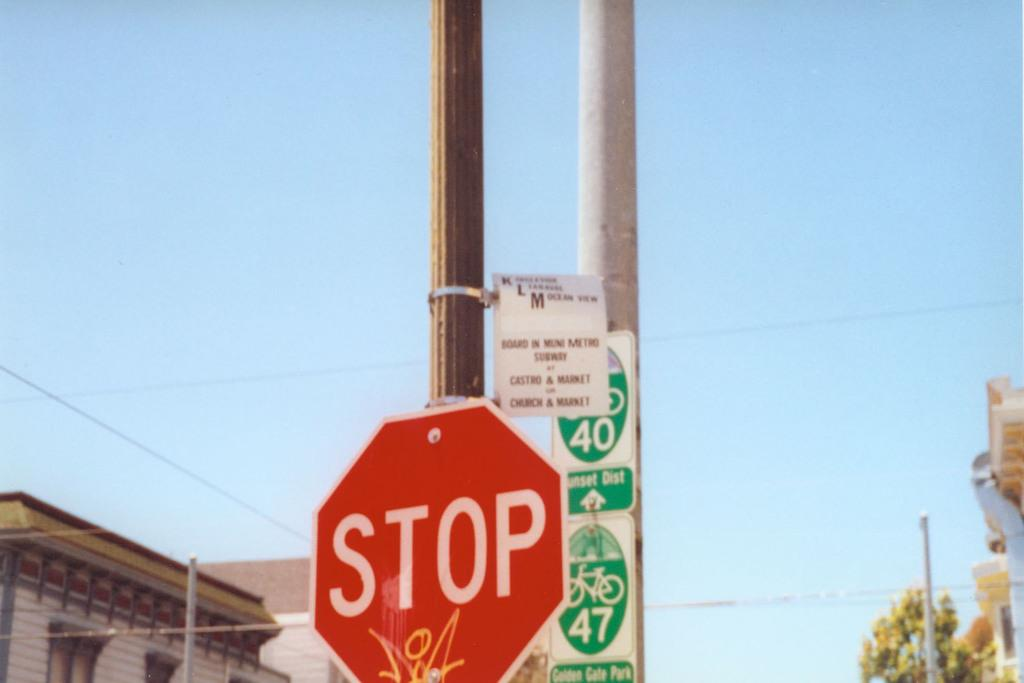Provide a one-sentence caption for the provided image. A Stop sign sits in front of a 40 and 47 sign with Bicycles on them. 